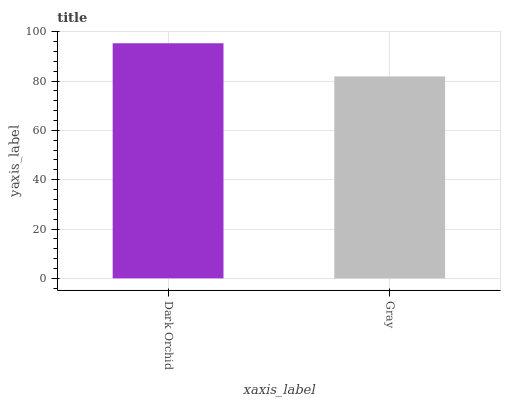Is Gray the maximum?
Answer yes or no. No. Is Dark Orchid greater than Gray?
Answer yes or no. Yes. Is Gray less than Dark Orchid?
Answer yes or no. Yes. Is Gray greater than Dark Orchid?
Answer yes or no. No. Is Dark Orchid less than Gray?
Answer yes or no. No. Is Dark Orchid the high median?
Answer yes or no. Yes. Is Gray the low median?
Answer yes or no. Yes. Is Gray the high median?
Answer yes or no. No. Is Dark Orchid the low median?
Answer yes or no. No. 